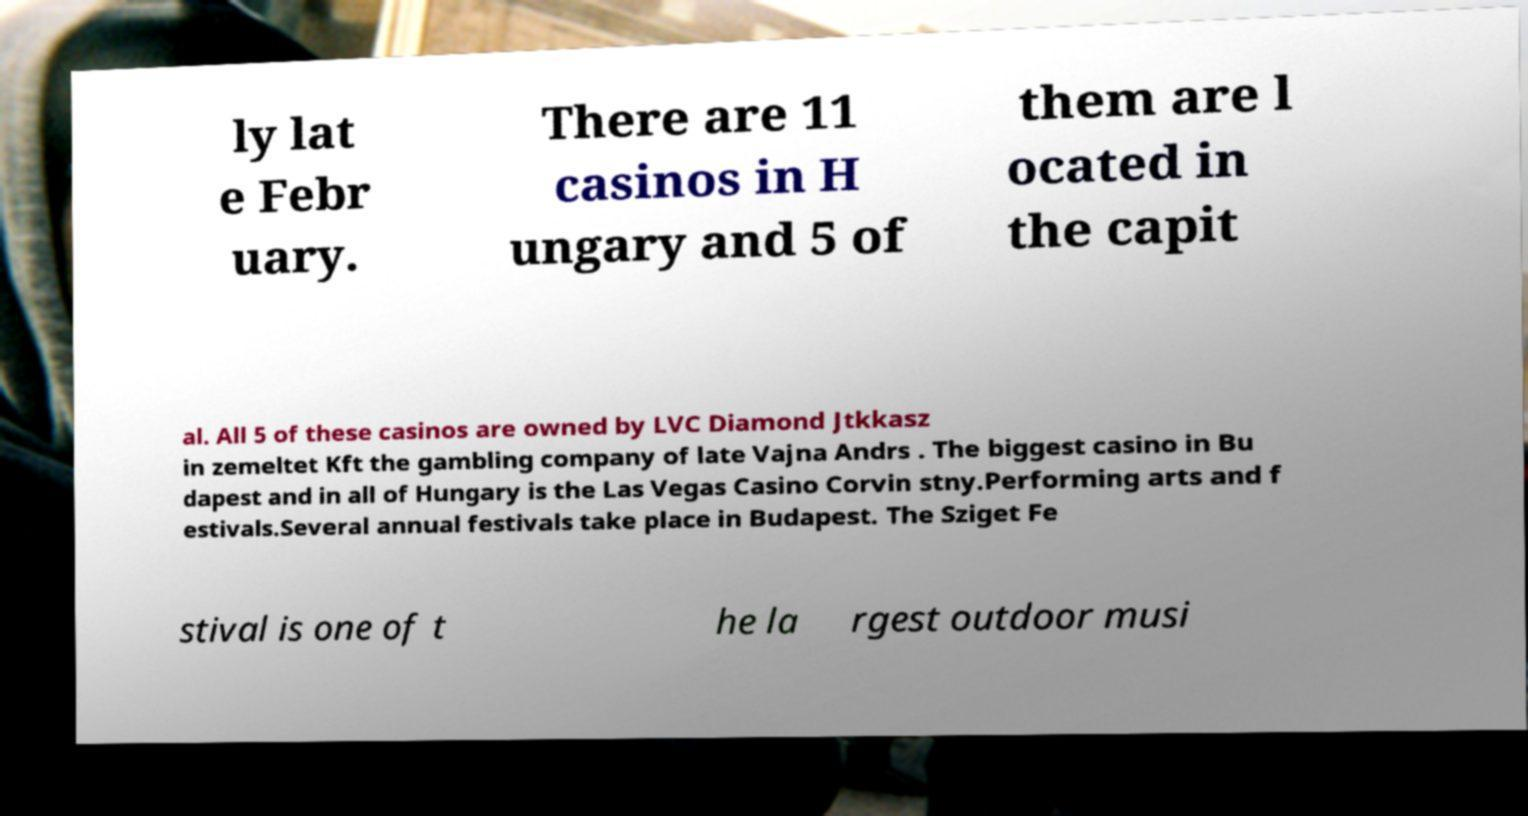Could you extract and type out the text from this image? ly lat e Febr uary. There are 11 casinos in H ungary and 5 of them are l ocated in the capit al. All 5 of these casinos are owned by LVC Diamond Jtkkasz in zemeltet Kft the gambling company of late Vajna Andrs . The biggest casino in Bu dapest and in all of Hungary is the Las Vegas Casino Corvin stny.Performing arts and f estivals.Several annual festivals take place in Budapest. The Sziget Fe stival is one of t he la rgest outdoor musi 